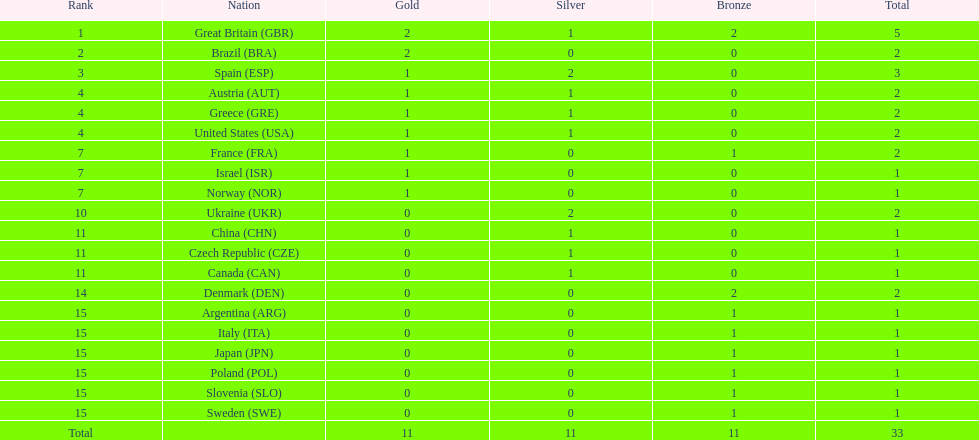Which state was next to great britain in cumulative medal count? Spain. 